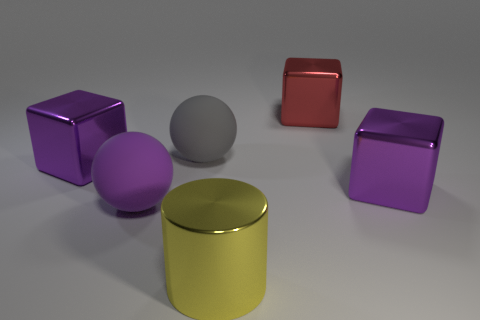There is another large thing that is the same shape as the big gray rubber object; what is its color?
Offer a very short reply. Purple. Does the large purple thing on the right side of the big yellow metal object have the same material as the purple block that is on the left side of the big gray rubber ball?
Your answer should be very brief. Yes. What is the size of the cylinder?
Keep it short and to the point. Large. There is a gray rubber object that is the same shape as the big purple matte object; what is its size?
Provide a succinct answer. Large. What number of purple metallic things are on the left side of the yellow thing?
Your answer should be compact. 1. What is the color of the metallic thing that is on the left side of the large rubber thing behind the big purple rubber sphere?
Your response must be concise. Purple. Is there anything else that is the same shape as the big gray object?
Keep it short and to the point. Yes. Are there the same number of big purple cubes that are behind the gray object and large spheres that are in front of the purple rubber ball?
Provide a succinct answer. Yes. How many cubes are gray rubber objects or metal objects?
Provide a short and direct response. 3. How many other objects are there of the same material as the large red thing?
Your response must be concise. 3. 